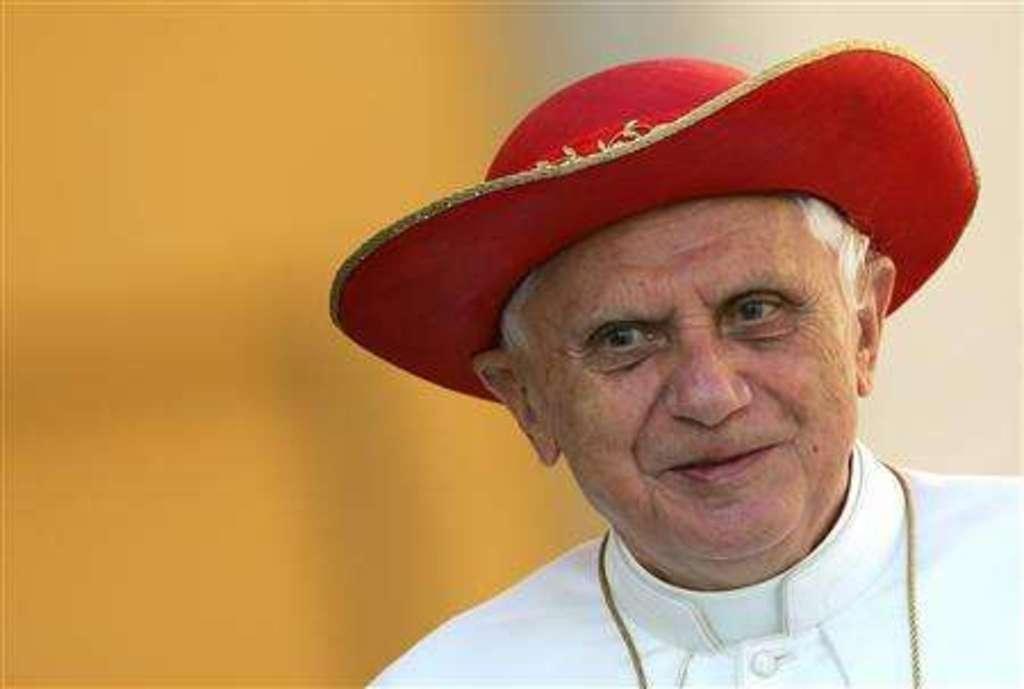In one or two sentences, can you explain what this image depicts? In this picture I can see a man in front and I see that he is wearing white color dress and a red color hat on his head. I see that it is blurred in the background. 